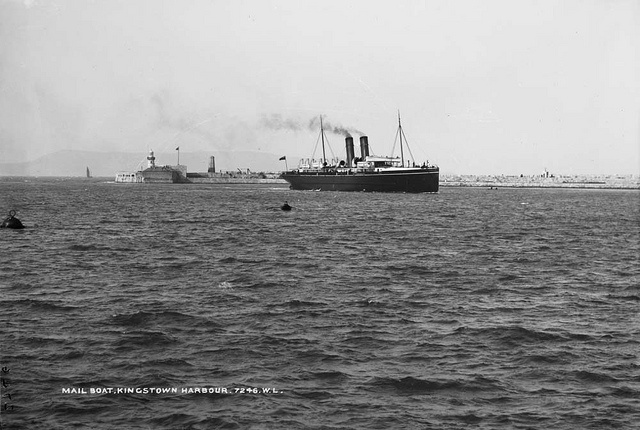Describe the objects in this image and their specific colors. I can see boat in lightgray, black, darkgray, and gray tones and boat in lightgray, darkgray, dimgray, and black tones in this image. 